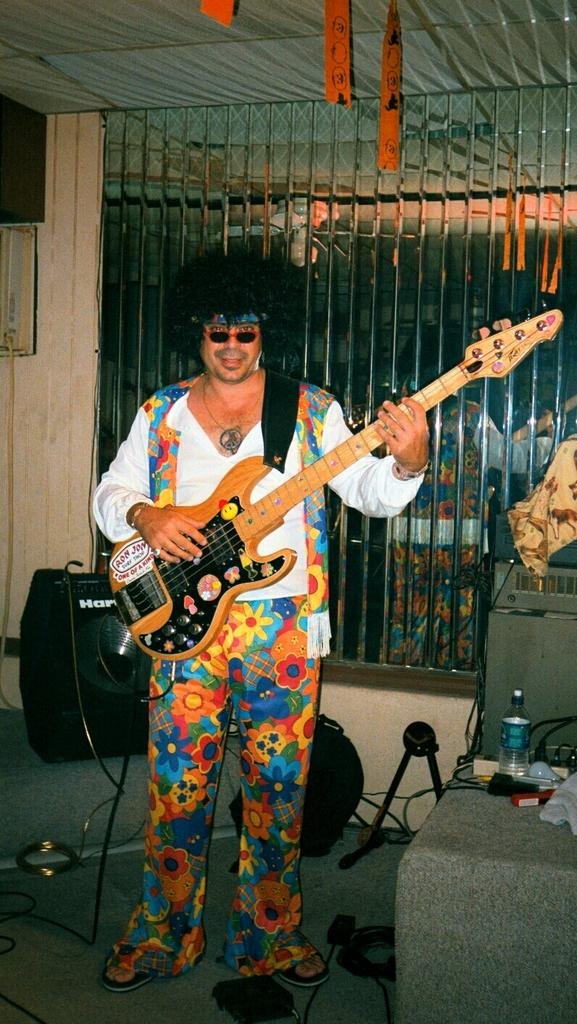What is the color of the wall in the image? The wall in the image is white. What is the man in the image doing? The man is holding a guitar. Can you describe the man's activity in the image? The man appears to be playing or holding the guitar, possibly as part of a performance or practice session. How many glasses of water does the man have on the wall in the image? There are no glasses of water present on the wall in the image. 